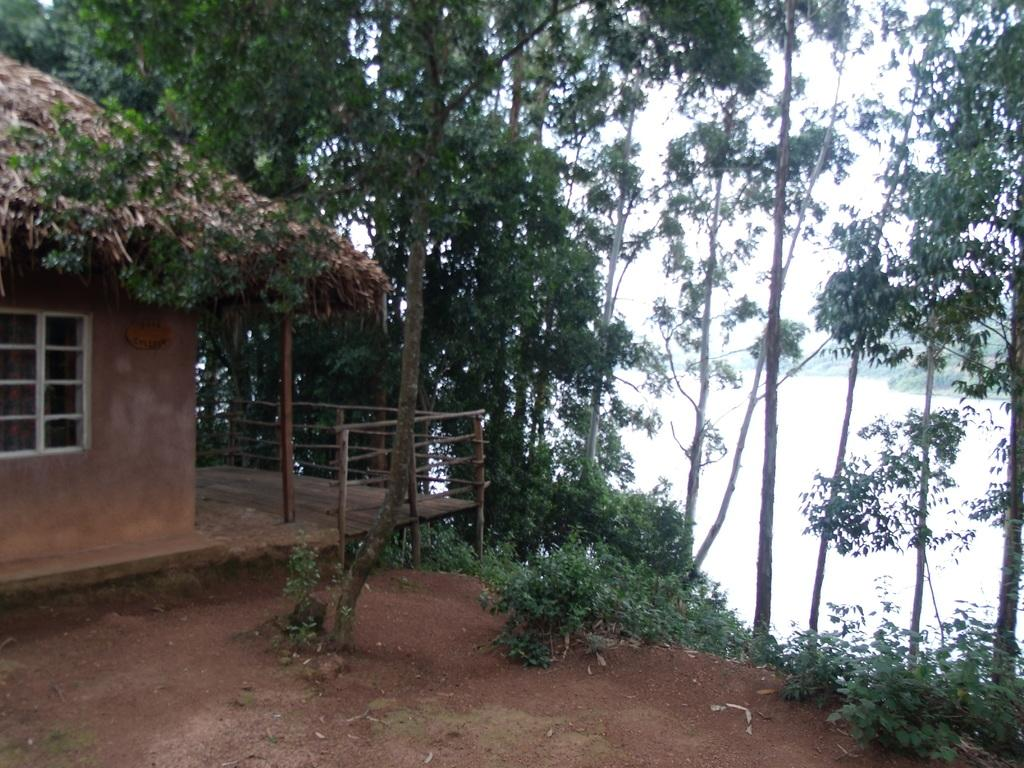What type of surface is visible in the image? There is ground visible in the image. What is the color of the house in the image? The house in the image is brown and white in color. What material is used for the railing in the image? There is a wooden railing in the image. What type of vegetation is present in the image? There are trees in the image. What can be seen in the distance in the image? There is water visible in the background of the image, and the sky is also visible. What type of wool is being spun on the spinning wheel in the image? There is no spinning wheel or wool present in the image. What type of skirt is the person wearing in the image? There is no person or skirt present in the image. 